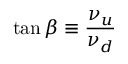<formula> <loc_0><loc_0><loc_500><loc_500>\tan \beta \equiv \frac { \nu _ { u } } { \nu _ { d } }</formula> 